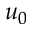Convert formula to latex. <formula><loc_0><loc_0><loc_500><loc_500>u _ { 0 }</formula> 